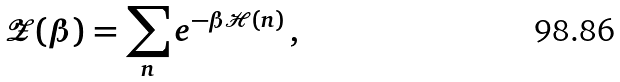Convert formula to latex. <formula><loc_0><loc_0><loc_500><loc_500>\mathcal { Z } ( \beta ) = \sum _ { n } e ^ { - \beta \mathcal { H } ( n ) } \, ,</formula> 